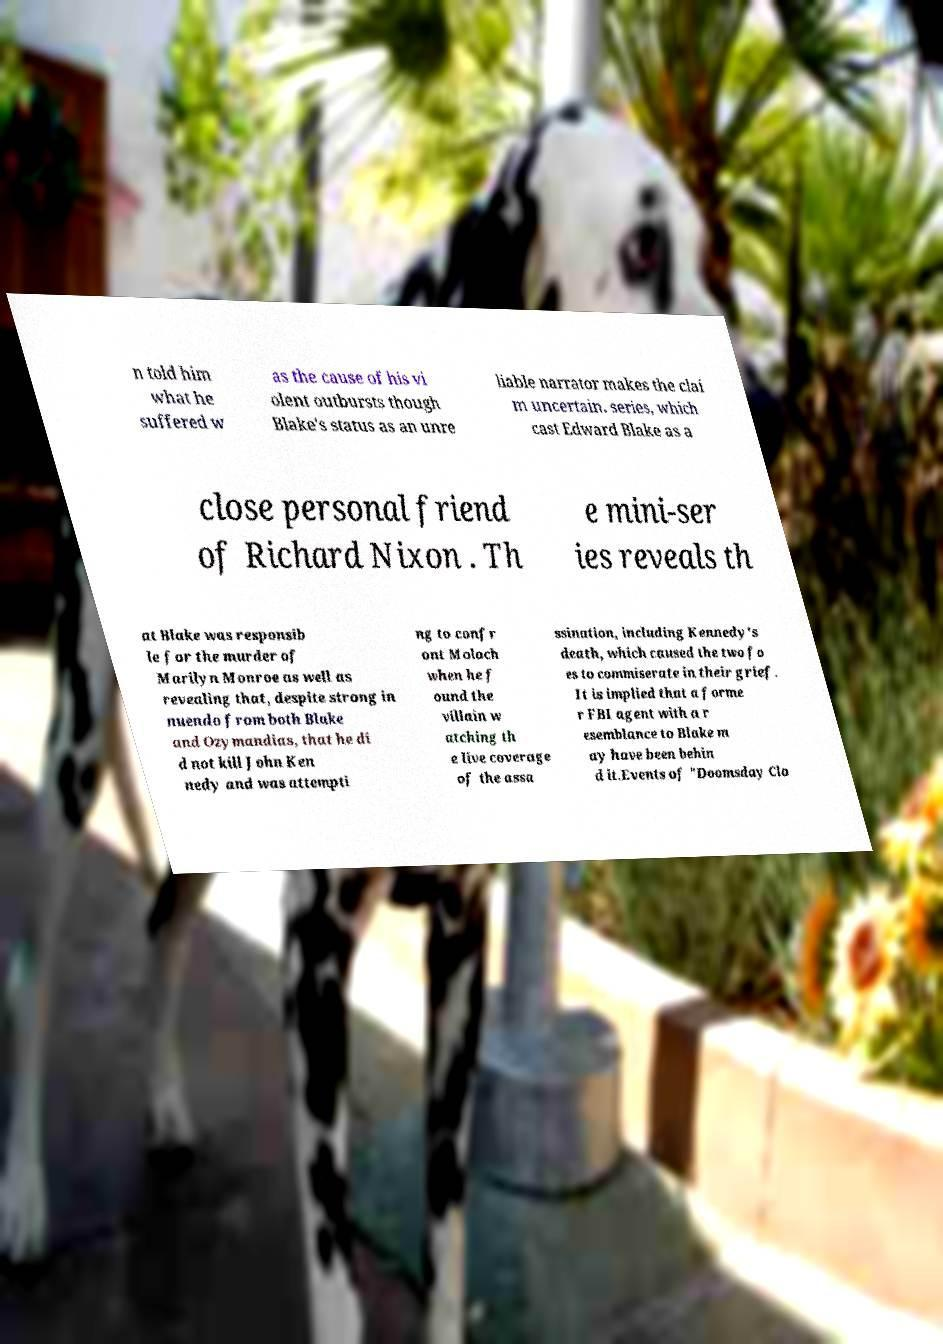I need the written content from this picture converted into text. Can you do that? n told him what he suffered w as the cause of his vi olent outbursts though Blake's status as an unre liable narrator makes the clai m uncertain. series, which cast Edward Blake as a close personal friend of Richard Nixon . Th e mini-ser ies reveals th at Blake was responsib le for the murder of Marilyn Monroe as well as revealing that, despite strong in nuendo from both Blake and Ozymandias, that he di d not kill John Ken nedy and was attempti ng to confr ont Moloch when he f ound the villain w atching th e live coverage of the assa ssination, including Kennedy's death, which caused the two fo es to commiserate in their grief. It is implied that a forme r FBI agent with a r esemblance to Blake m ay have been behin d it.Events of "Doomsday Clo 